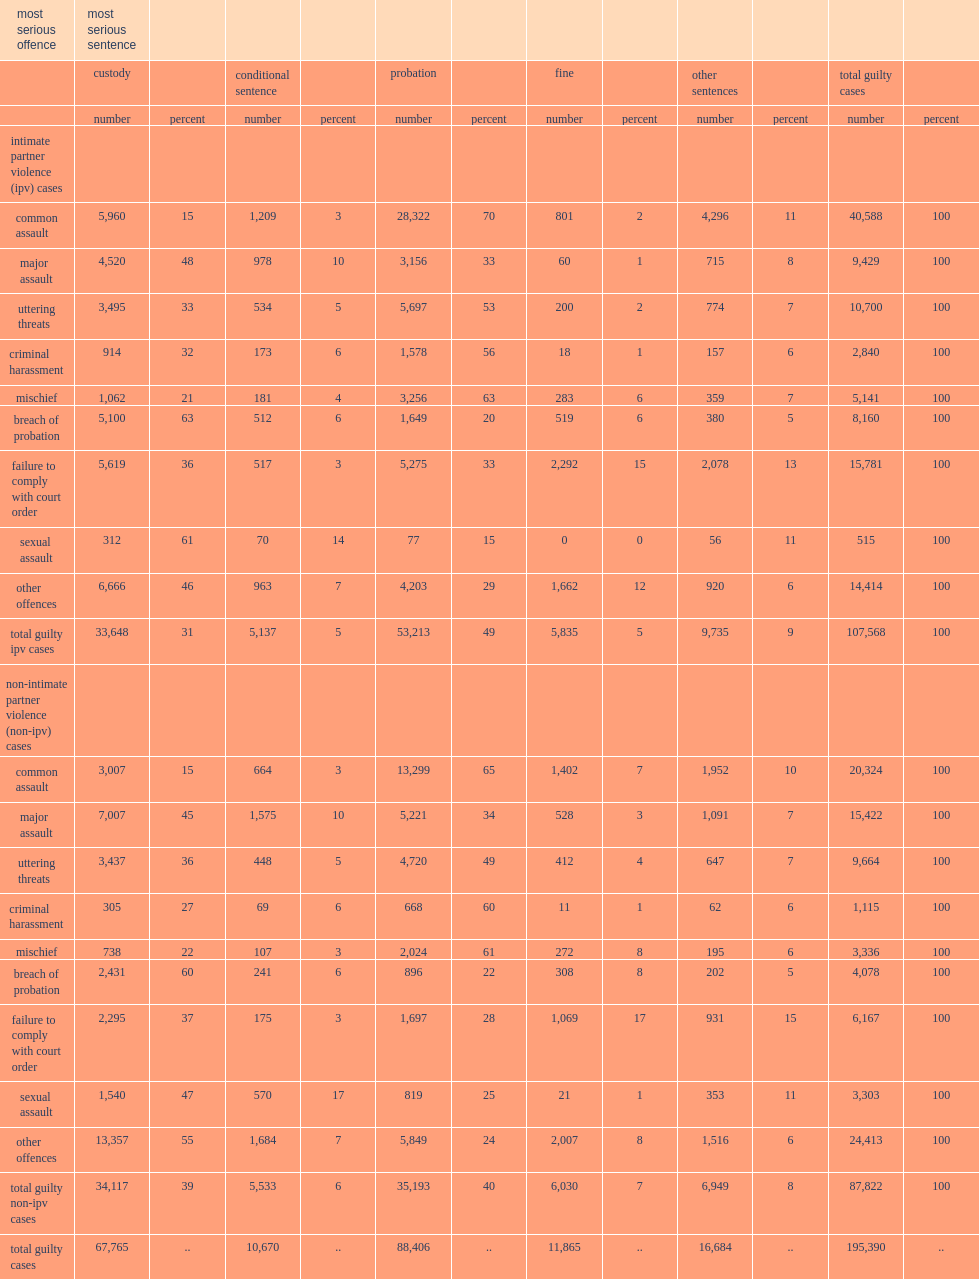Which type of cases is less likely to result in a sentence of custody?non-ipv cases or ipv cases? Intimate partner violence (ipv) cases. 